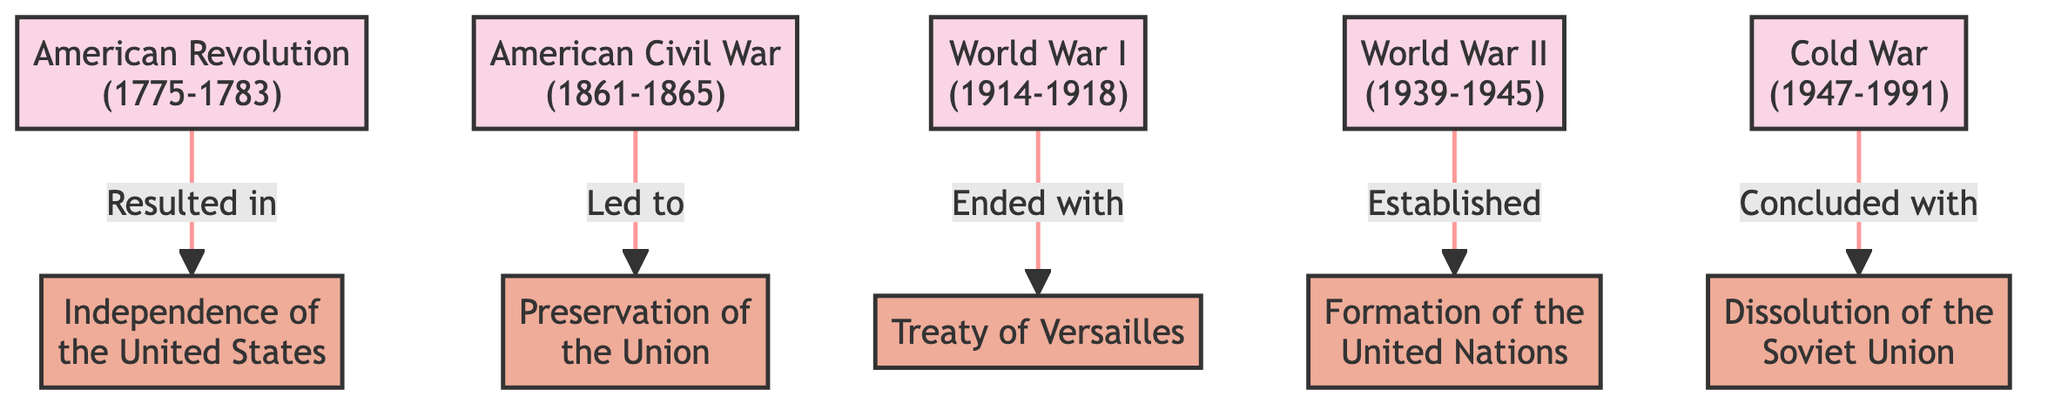What major conflict resulted in the Independence of the United States? The diagram shows the direct connection between "American Revolution" and "Independence of the United States." This indicates that the American Revolution was the conflict that led to this outcome.
Answer: American Revolution How many major military conflicts are shown in the diagram? By counting the nodes labeled as conflicts, there are five distinct conflicts represented: American Revolution, American Civil War, World War I, World War II, and Cold War.
Answer: Five What was the outcome of World War II? The diagram illustrates that World War II is connected to the outcome labeled "Formation of the United Nations." This indicates that this was the primary outcome of World War II.
Answer: Formation of the United Nations What two outcomes resulted from the American Civil War? The diagram shows that the American Civil War directly leads to the "Preservation of the Union." This means it had a significant outcome related to maintaining the nation's structure, but there is only one explicitly mentioned outcome linked to this war in the diagram.
Answer: Preservation of the Union Which conflict ended with the Treaty of Versailles? The visual shows a link from "World War I" to "Treaty of Versailles," indicating that the treaty was the official outcome that concluded the conflict of World War I.
Answer: World War I What does the Cold War conclude with? The Cold War node has a direct connection to the "Dissolution of the Soviet Union." This signifies that the end of the Cold War is tied to this specific outcome.
Answer: Dissolution of the Soviet Union Is the American Revolution connected to more than one outcome? The diagram illustrates that the American Revolution has only one directed edge leading to "Independence of the United States," meaning it is not connected to multiple outcomes.
Answer: No What type of relationship exists between World War I and its outcome? The diagram reflects a directed relationship from World War I to "Treaty of Versailles," indicating that it ended with this particular outcome. The relationship is one-way, signifying a causative effect.
Answer: Ended with 